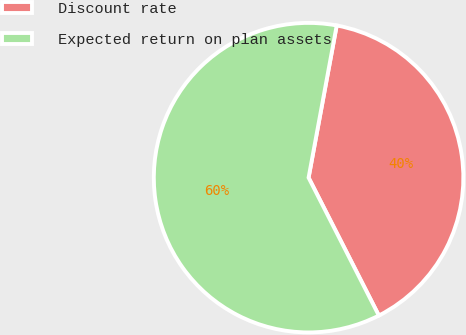<chart> <loc_0><loc_0><loc_500><loc_500><pie_chart><fcel>Discount rate<fcel>Expected return on plan assets<nl><fcel>39.59%<fcel>60.41%<nl></chart> 